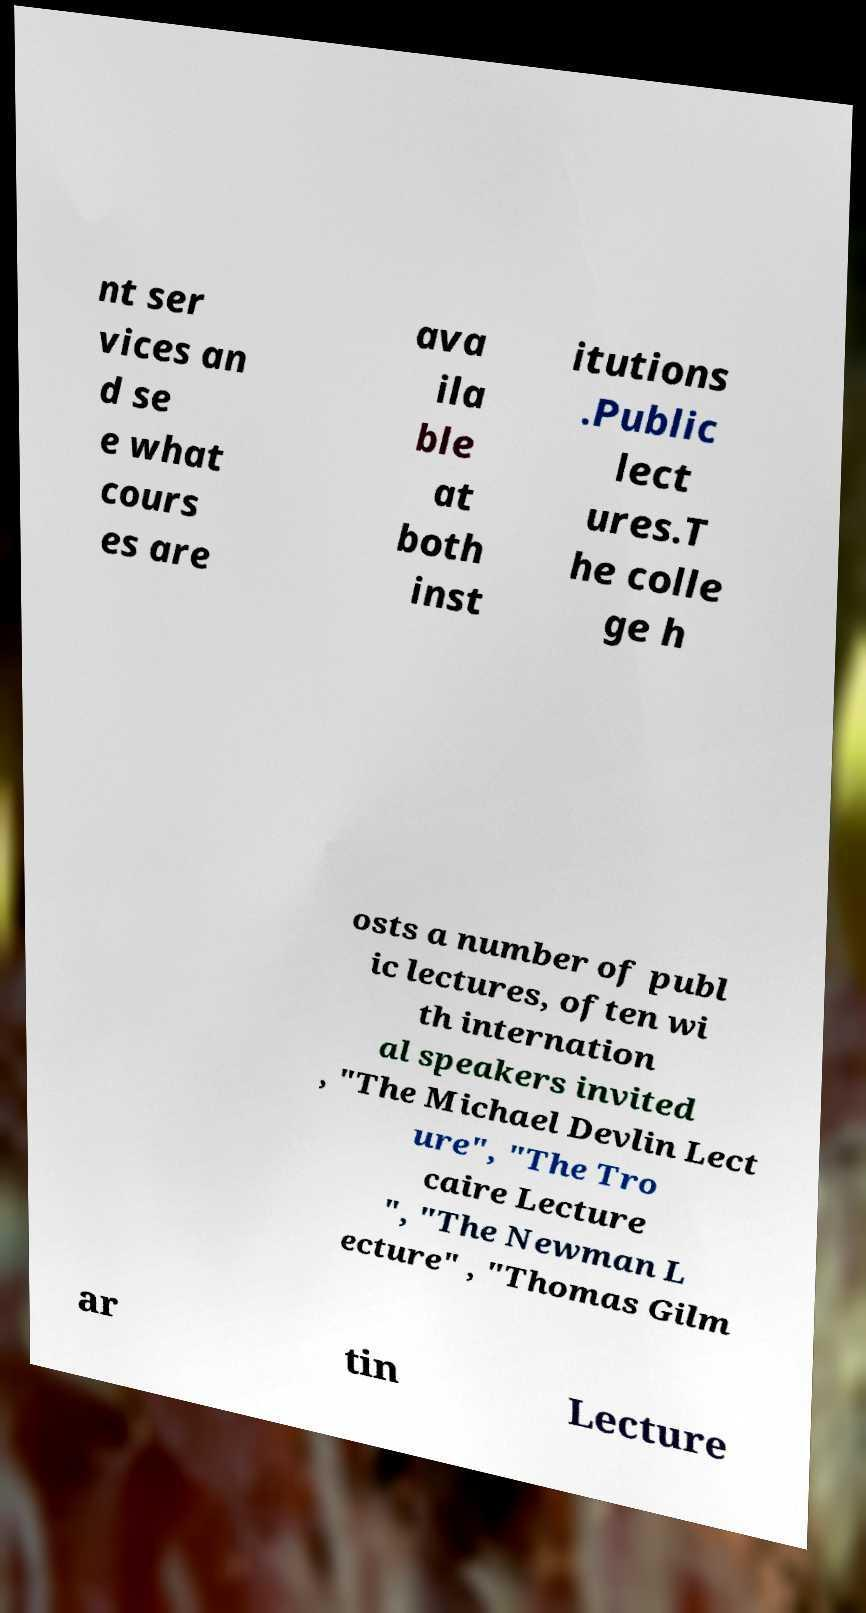There's text embedded in this image that I need extracted. Can you transcribe it verbatim? nt ser vices an d se e what cours es are ava ila ble at both inst itutions .Public lect ures.T he colle ge h osts a number of publ ic lectures, often wi th internation al speakers invited , "The Michael Devlin Lect ure", "The Tro caire Lecture ", "The Newman L ecture" , "Thomas Gilm ar tin Lecture 